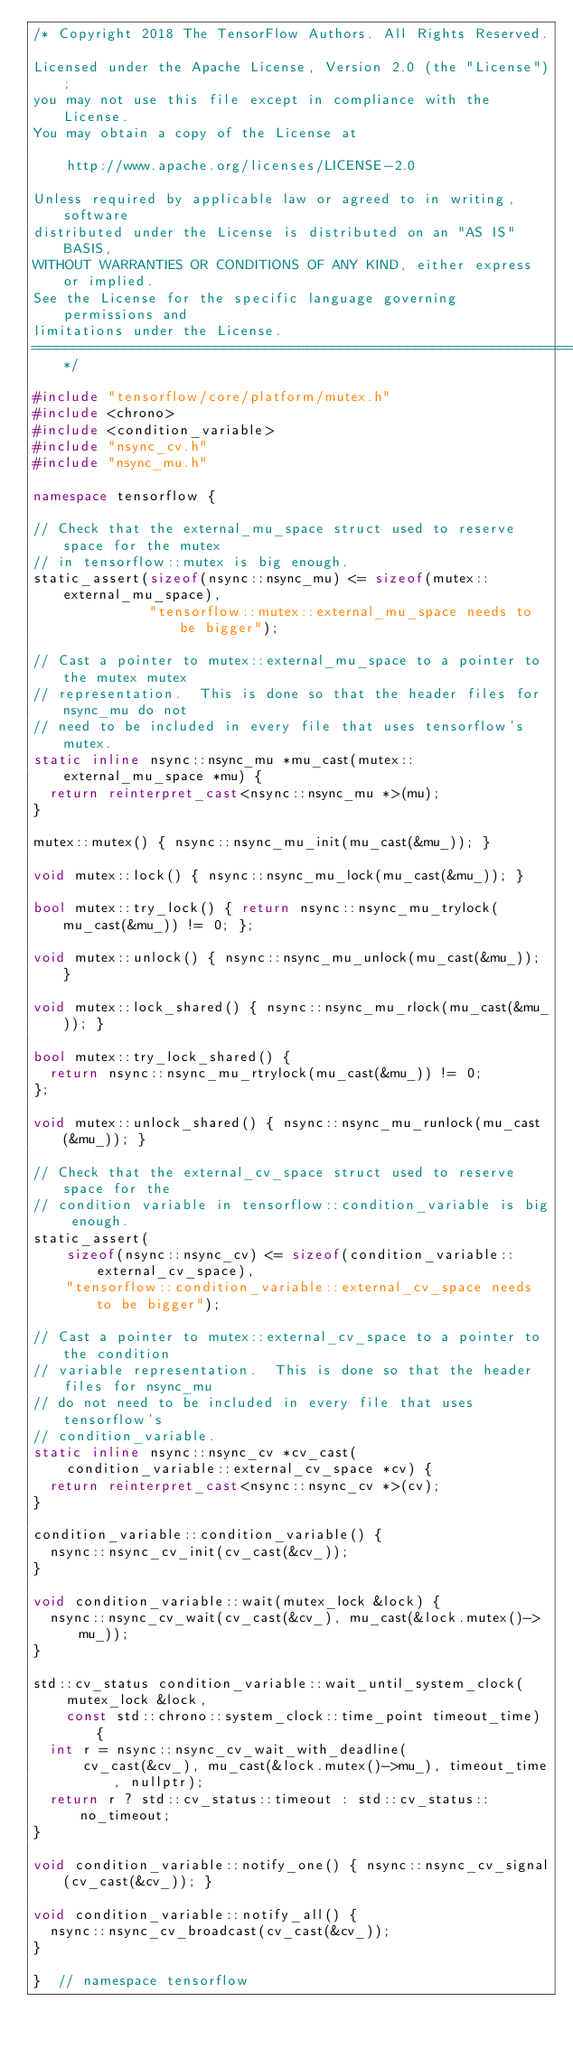Convert code to text. <code><loc_0><loc_0><loc_500><loc_500><_C++_>/* Copyright 2018 The TensorFlow Authors. All Rights Reserved.

Licensed under the Apache License, Version 2.0 (the "License");
you may not use this file except in compliance with the License.
You may obtain a copy of the License at

    http://www.apache.org/licenses/LICENSE-2.0

Unless required by applicable law or agreed to in writing, software
distributed under the License is distributed on an "AS IS" BASIS,
WITHOUT WARRANTIES OR CONDITIONS OF ANY KIND, either express or implied.
See the License for the specific language governing permissions and
limitations under the License.
==============================================================================*/

#include "tensorflow/core/platform/mutex.h"
#include <chrono>
#include <condition_variable>
#include "nsync_cv.h"
#include "nsync_mu.h"

namespace tensorflow {

// Check that the external_mu_space struct used to reserve space for the mutex
// in tensorflow::mutex is big enough.
static_assert(sizeof(nsync::nsync_mu) <= sizeof(mutex::external_mu_space),
              "tensorflow::mutex::external_mu_space needs to be bigger");

// Cast a pointer to mutex::external_mu_space to a pointer to the mutex mutex
// representation.  This is done so that the header files for nsync_mu do not
// need to be included in every file that uses tensorflow's mutex.
static inline nsync::nsync_mu *mu_cast(mutex::external_mu_space *mu) {
  return reinterpret_cast<nsync::nsync_mu *>(mu);
}

mutex::mutex() { nsync::nsync_mu_init(mu_cast(&mu_)); }

void mutex::lock() { nsync::nsync_mu_lock(mu_cast(&mu_)); }

bool mutex::try_lock() { return nsync::nsync_mu_trylock(mu_cast(&mu_)) != 0; };

void mutex::unlock() { nsync::nsync_mu_unlock(mu_cast(&mu_)); }

void mutex::lock_shared() { nsync::nsync_mu_rlock(mu_cast(&mu_)); }

bool mutex::try_lock_shared() {
  return nsync::nsync_mu_rtrylock(mu_cast(&mu_)) != 0;
};

void mutex::unlock_shared() { nsync::nsync_mu_runlock(mu_cast(&mu_)); }

// Check that the external_cv_space struct used to reserve space for the
// condition variable in tensorflow::condition_variable is big enough.
static_assert(
    sizeof(nsync::nsync_cv) <= sizeof(condition_variable::external_cv_space),
    "tensorflow::condition_variable::external_cv_space needs to be bigger");

// Cast a pointer to mutex::external_cv_space to a pointer to the condition
// variable representation.  This is done so that the header files for nsync_mu
// do not need to be included in every file that uses tensorflow's
// condition_variable.
static inline nsync::nsync_cv *cv_cast(
    condition_variable::external_cv_space *cv) {
  return reinterpret_cast<nsync::nsync_cv *>(cv);
}

condition_variable::condition_variable() {
  nsync::nsync_cv_init(cv_cast(&cv_));
}

void condition_variable::wait(mutex_lock &lock) {
  nsync::nsync_cv_wait(cv_cast(&cv_), mu_cast(&lock.mutex()->mu_));
}

std::cv_status condition_variable::wait_until_system_clock(
    mutex_lock &lock,
    const std::chrono::system_clock::time_point timeout_time) {
  int r = nsync::nsync_cv_wait_with_deadline(
      cv_cast(&cv_), mu_cast(&lock.mutex()->mu_), timeout_time, nullptr);
  return r ? std::cv_status::timeout : std::cv_status::no_timeout;
}

void condition_variable::notify_one() { nsync::nsync_cv_signal(cv_cast(&cv_)); }

void condition_variable::notify_all() {
  nsync::nsync_cv_broadcast(cv_cast(&cv_));
}

}  // namespace tensorflow
</code> 